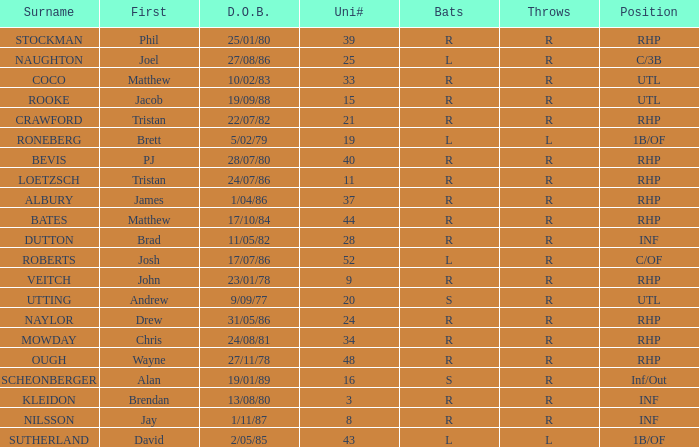How many Uni numbers have Bats of s, and a Position of utl? 1.0. 